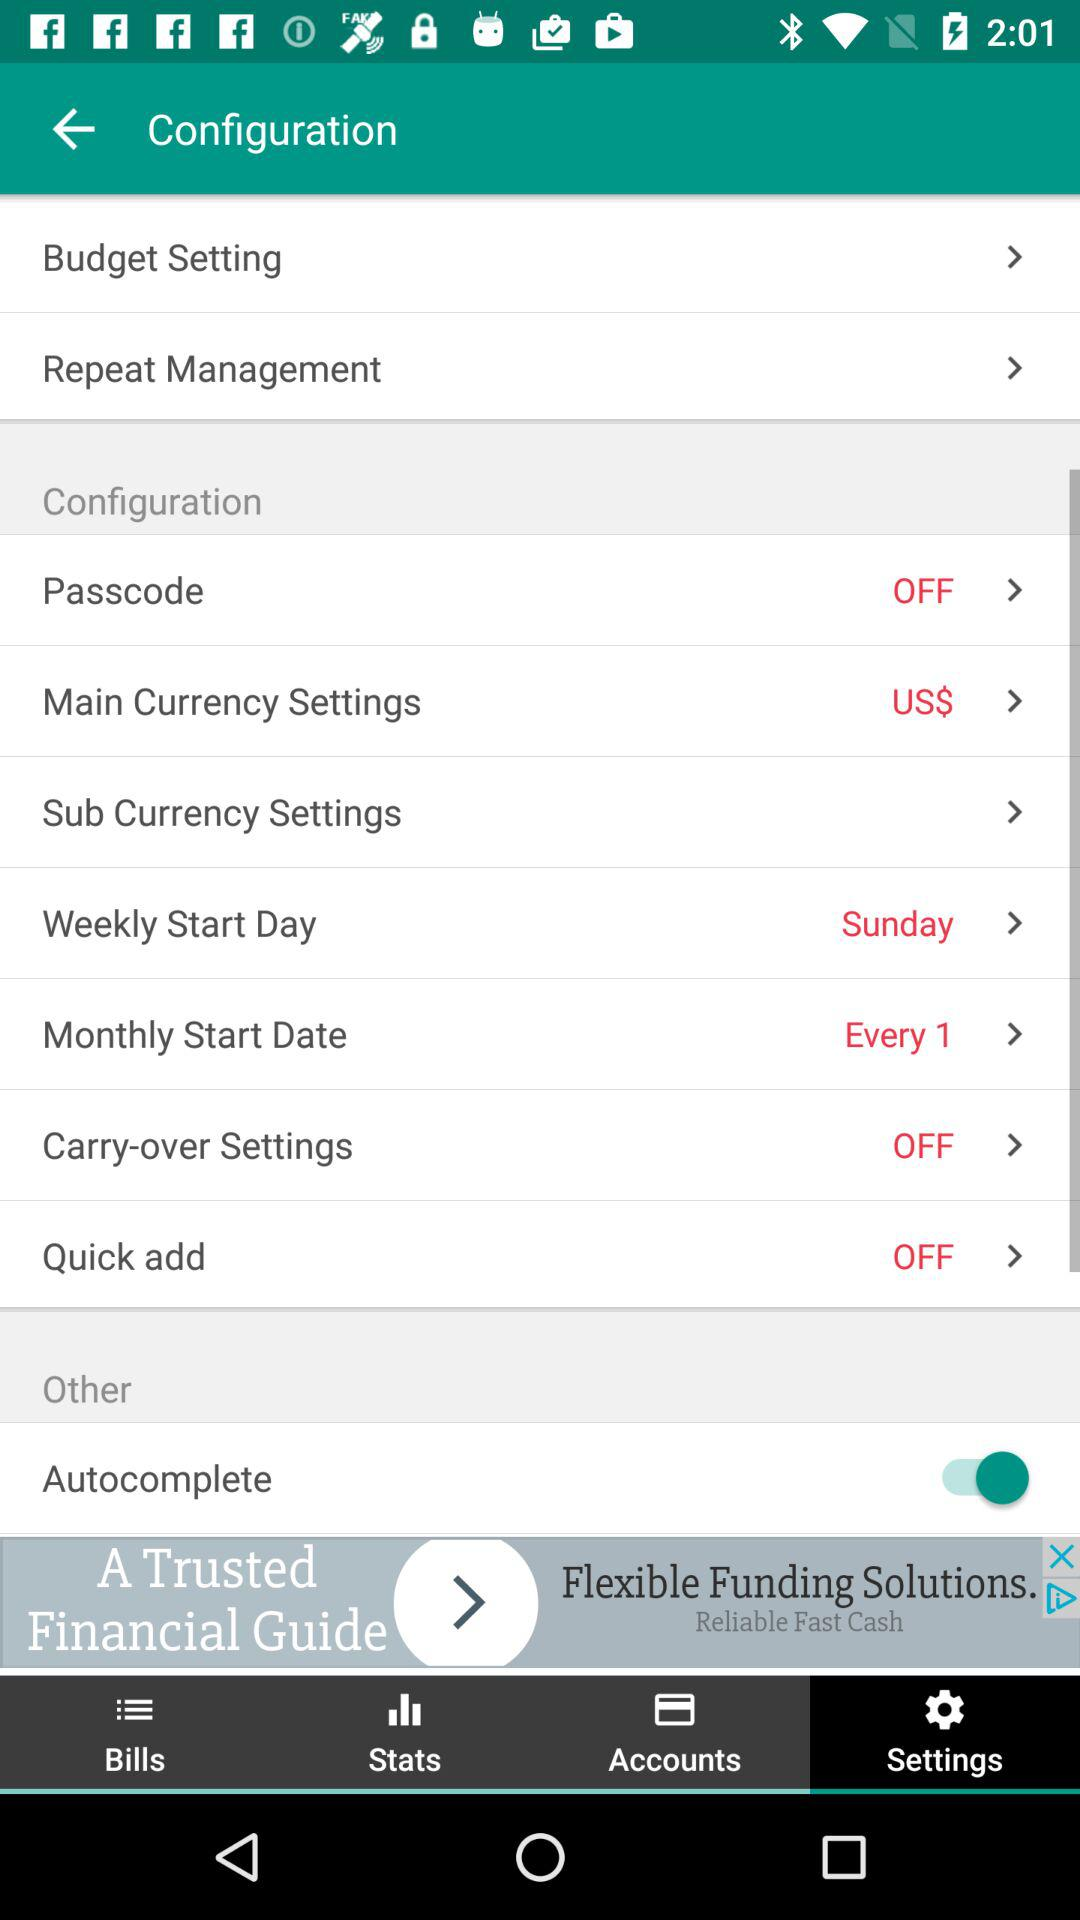What is the setting for "Quick add"? The setting for "Quick add" is "off". 